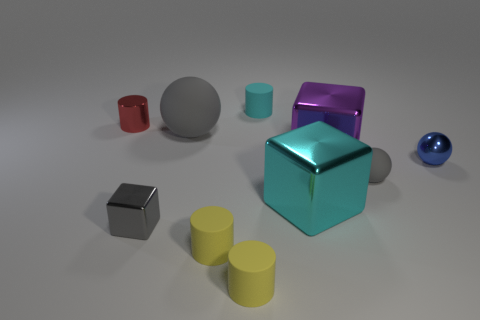Subtract all cyan rubber cylinders. How many cylinders are left? 3 Subtract all cylinders. How many objects are left? 6 Add 4 small shiny balls. How many small shiny balls are left? 5 Add 5 tiny blue objects. How many tiny blue objects exist? 6 Subtract all cyan blocks. How many blocks are left? 2 Subtract 0 brown blocks. How many objects are left? 10 Subtract 1 balls. How many balls are left? 2 Subtract all yellow spheres. Subtract all green cylinders. How many spheres are left? 3 Subtract all cyan spheres. How many yellow cylinders are left? 2 Subtract all tiny gray rubber balls. Subtract all large gray metal cubes. How many objects are left? 9 